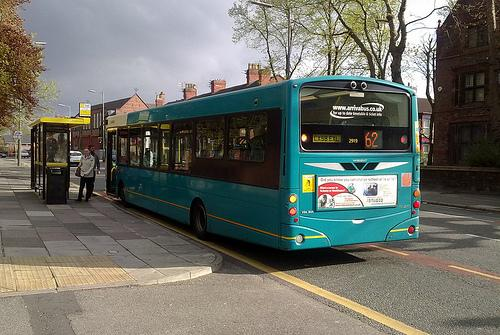Identify the color and type of the vehicle present in the image. There is a teal or turquoise-colored passenger bus in the image. For the multi-choice VQA task, which of the following options best describes the bus' visible area: front, back or side? The back of the turquoise passenger bus is visible in the image. Describe the weather and surroundings of this scene. The scene seems to have a dark and grey sky, with tall trees in the distance and a nearby city sidewalk. In a short description, mention the presence of any advertisement in the image. An ad can be seen on the back of the turquoise bus in the image. What type of trees can be seen in the image, and where are they located? There are tall trees in the distance and brown and green tree leaves appear in the image, clustered against the sky. What is unusual about one of the buildings in the image? There are spikes on the top of one of the buildings. What type of shelter or structure is near the bus stop? There is a yellow and black passenger bus shelter near the bus stop. For the product advertisement task, identify one object or location where an advertisement is placed in the image. An advertisement is placed on the back of the turquoise passenger bus. For the visual entailment task, mention if there is an odd architectural feature in the image. Yes, there are spikes on the top of one of the buildings in the image. Provide a caption describing the main action happening in the image. A turquoise bus with the number 62 is dropping people off at a bus stop while passengers wait for their turn to board. 